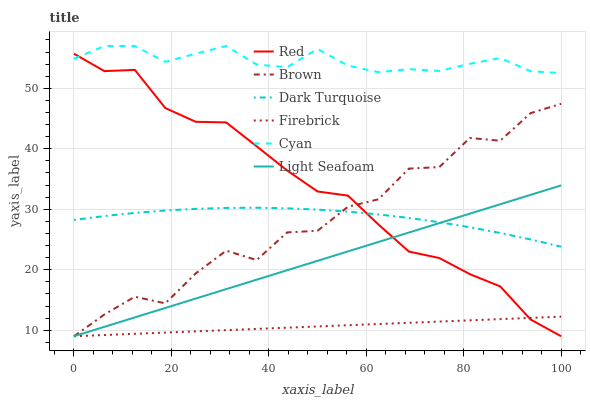Does Firebrick have the minimum area under the curve?
Answer yes or no. Yes. Does Cyan have the maximum area under the curve?
Answer yes or no. Yes. Does Dark Turquoise have the minimum area under the curve?
Answer yes or no. No. Does Dark Turquoise have the maximum area under the curve?
Answer yes or no. No. Is Firebrick the smoothest?
Answer yes or no. Yes. Is Brown the roughest?
Answer yes or no. Yes. Is Dark Turquoise the smoothest?
Answer yes or no. No. Is Dark Turquoise the roughest?
Answer yes or no. No. Does Dark Turquoise have the lowest value?
Answer yes or no. No. Does Cyan have the highest value?
Answer yes or no. Yes. Does Dark Turquoise have the highest value?
Answer yes or no. No. Is Firebrick less than Cyan?
Answer yes or no. Yes. Is Cyan greater than Brown?
Answer yes or no. Yes. Does Light Seafoam intersect Red?
Answer yes or no. Yes. Is Light Seafoam less than Red?
Answer yes or no. No. Is Light Seafoam greater than Red?
Answer yes or no. No. Does Firebrick intersect Cyan?
Answer yes or no. No. 